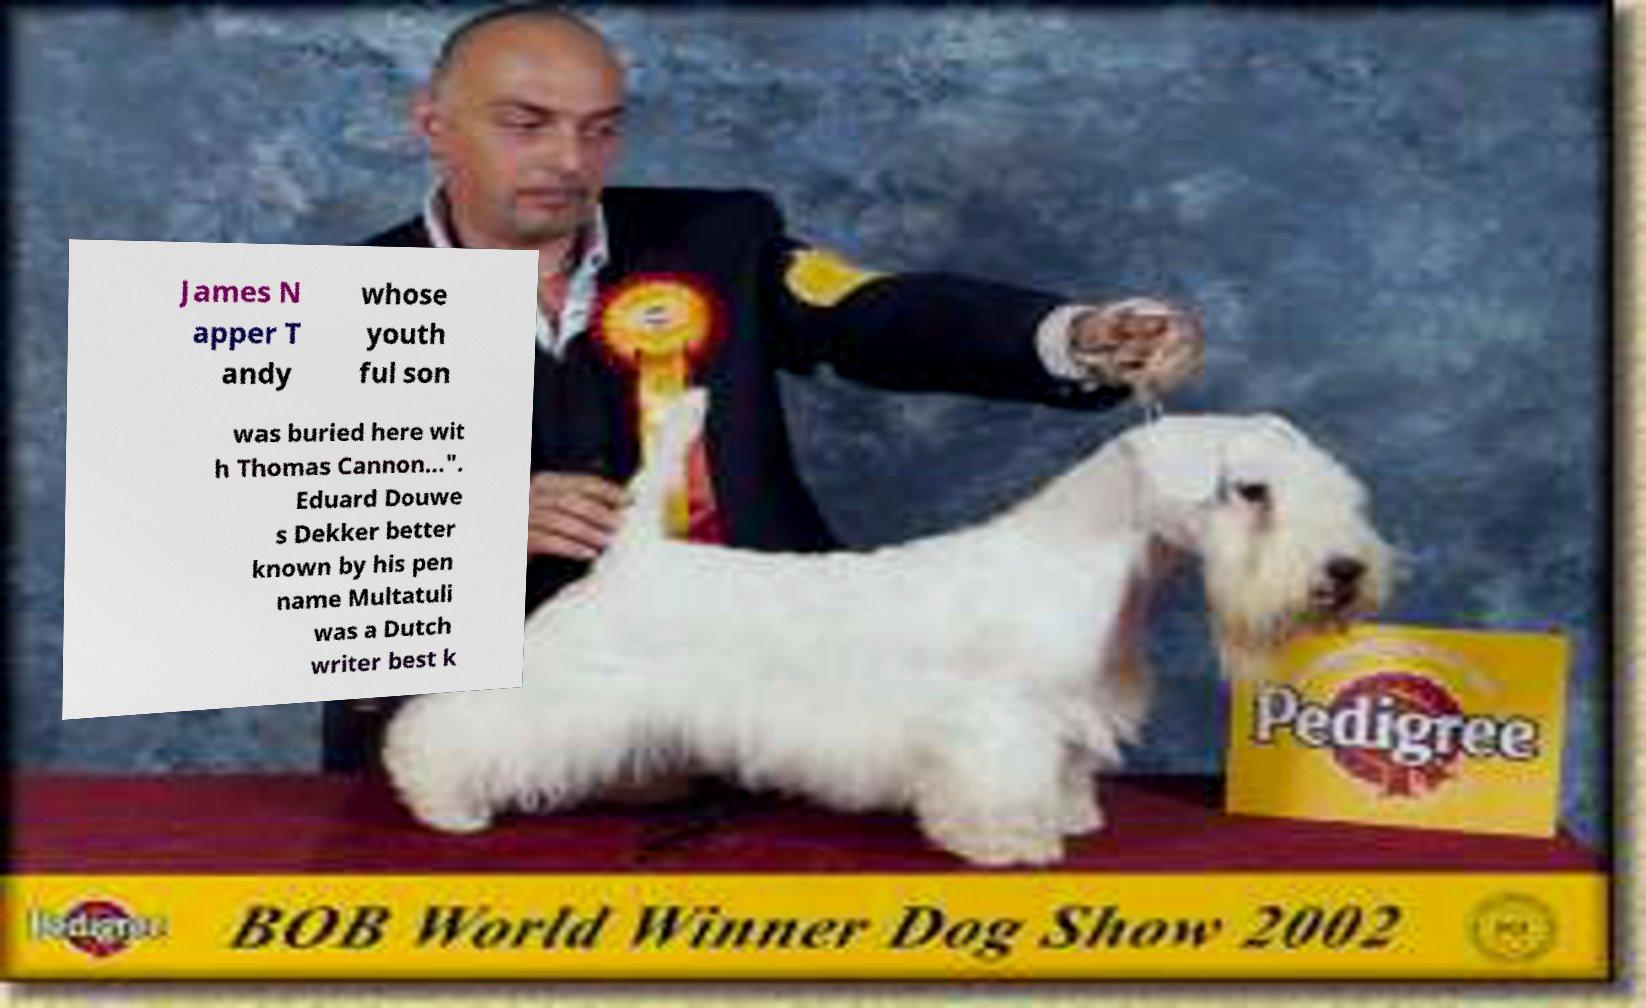Could you assist in decoding the text presented in this image and type it out clearly? James N apper T andy whose youth ful son was buried here wit h Thomas Cannon...". Eduard Douwe s Dekker better known by his pen name Multatuli was a Dutch writer best k 